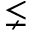<formula> <loc_0><loc_0><loc_500><loc_500>\lneq</formula> 